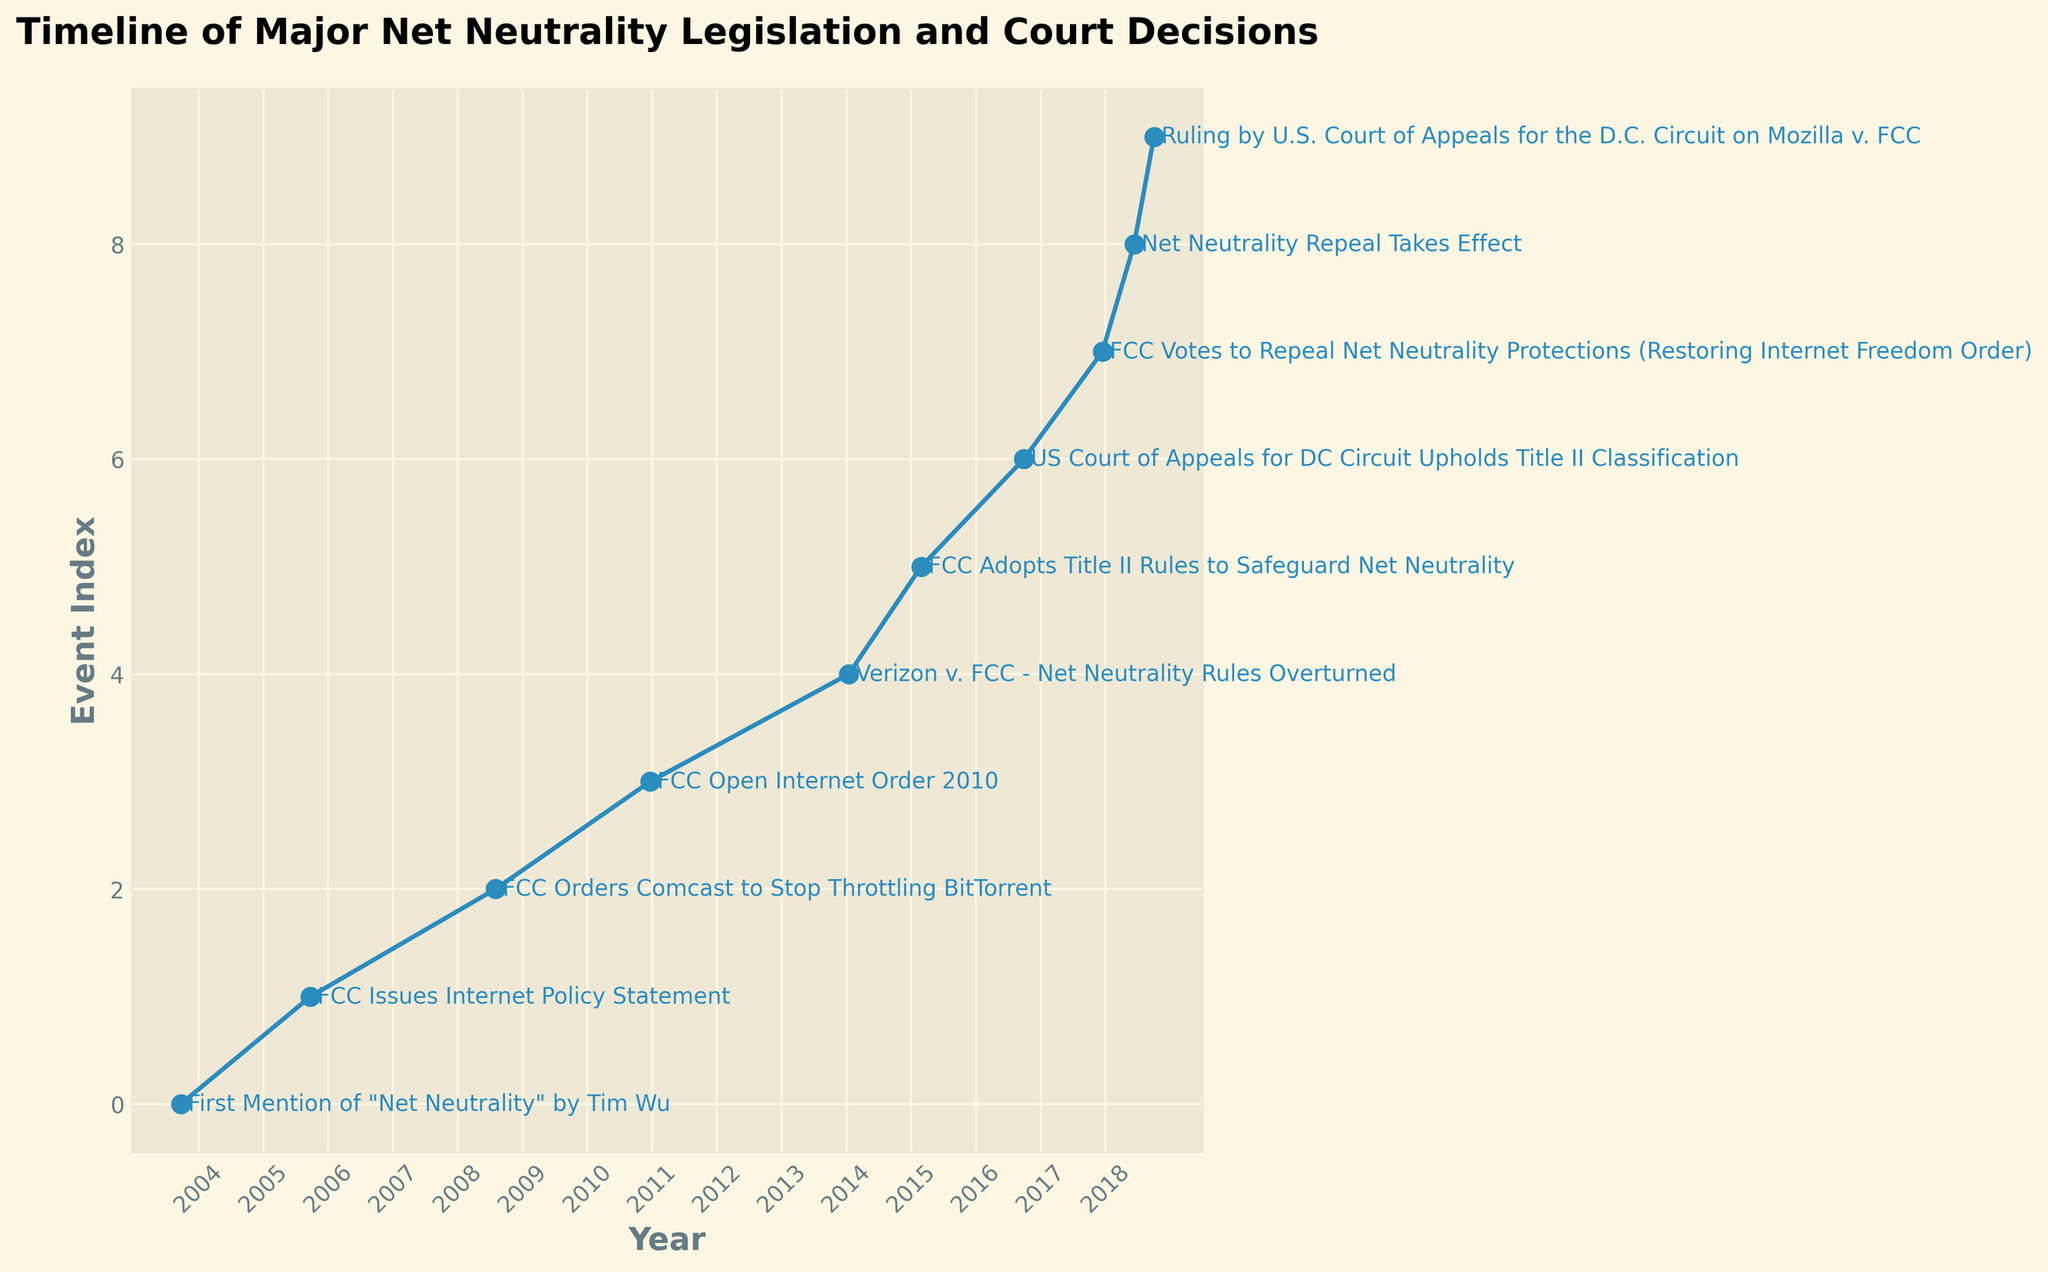What is the first event mentioned and in which year does it occur? The plot starts with the first timeline event, "First Mention of 'Net Neutrality' by Tim Wu," which is listed at the beginning of the line sequence. The corresponding date for this event is in 2003.
Answer: 2003 Which event occurred more recently, the FCC Open Internet Order 2010 or the US Court of Appeals for DC Circuit ruling in 2016? By observing the timeline, the FCC Open Internet Order 2010 happened earlier in 2010, while the US Court of Appeals for DC Circuit ruling happened later in 2016.
Answer: The US Court of Appeals for DC Circuit ruling in 2016 Counting from the left, what is the 5th event listed on the timeline? The timeline is ordered chronologically, and by counting the events listed starting from the left of the x-axis towards the right, the 5th event on the timeline is "Verizon v. FCC - Net Neutrality Rules Overturned."
Answer: Verizon v. FCC - Net Neutrality Rules Overturned Which event occurs between the "FCC Votes to Repeal Net Neutrality Protections" in 2017 and the "Ruling by U.S. Court of Appeals for the D.C. Circuit on Mozilla v. FCC" in 2018? By following the timeline sequence, the event that falls between the "FCC Votes to Repeal Net Neutrality Protections" in 2017 and the "Ruling by U.S. Court of Appeals for the D.C. Circuit on Mozilla v. FCC" in 2018 is "Net Neutrality Repeal Takes Effect."
Answer: Net Neutrality Repeal Takes Effect How many events are listed between the "FCC Orders Comcast to Stop Throttling BitTorrent" and the "FCC Open Internet Order 2010"? Reviewing the timeline sequence, we note that there is only one event that falls between "FCC Orders Comcast to Stop Throttling BitTorrent" in 2008 and "FCC Open Internet Order 2010" in 2010. This indicates a gap with no other events listed.
Answer: None What is the chronological order of the events that occurred in the year 2018? Referring to all events of 2018 on the timeline, we can identify the exact order based on their chronological sequence. First, "Net Neutrality Repeal Takes Effect" happens in June followed by "Ruling by U.S. Court of Appeals for the D.C. Circuit on Mozilla v. FCC" which occurs in October.
Answer: Net Neutrality Repeal Takes Effect, Ruling by U.S. Court of Appeals for the D.C. Circuit on Mozilla v. FCC Between the events "First Mention of 'Net Neutrality' by Tim Wu" and "FCC Orders Comcast to Stop Throttling BitTorrent," how much time elapsed (in years)? Calculating the time elapsed, the first event occurred in 2003 while the second event in concern happened in 2008. Thus, the difference between these years results in 5 years.
Answer: 5 years Are there more events before or after the 2010 FCC Open Internet Order? Viewing the placement within the timeline, there are three events before the FCC Open Internet Order in 2010, whereas six events follow after 2010. This simple comparison shows that post-2010 events outnumber the pre-2010 ones.
Answer: More events after Is the "FCC Issues Internet Policy Statement" closer to "First Mention of 'Net Neutrality' by Tim Wu" or to "FCC Orders Comcast to Stop Throttling BitTorrent"? Reviewing the timeline, "FCC Issues Internet Policy Statement" in 2005 falls closer to the "First Mention of 'Net Neutrality' by Tim Wu" in 2003 than to "FCC Orders Comcast to Stop Throttling BitTorrent" in 2008 based on the years in between.
Answer: Closer to "First Mention of 'Net Neutrality' by Tim Wu" 